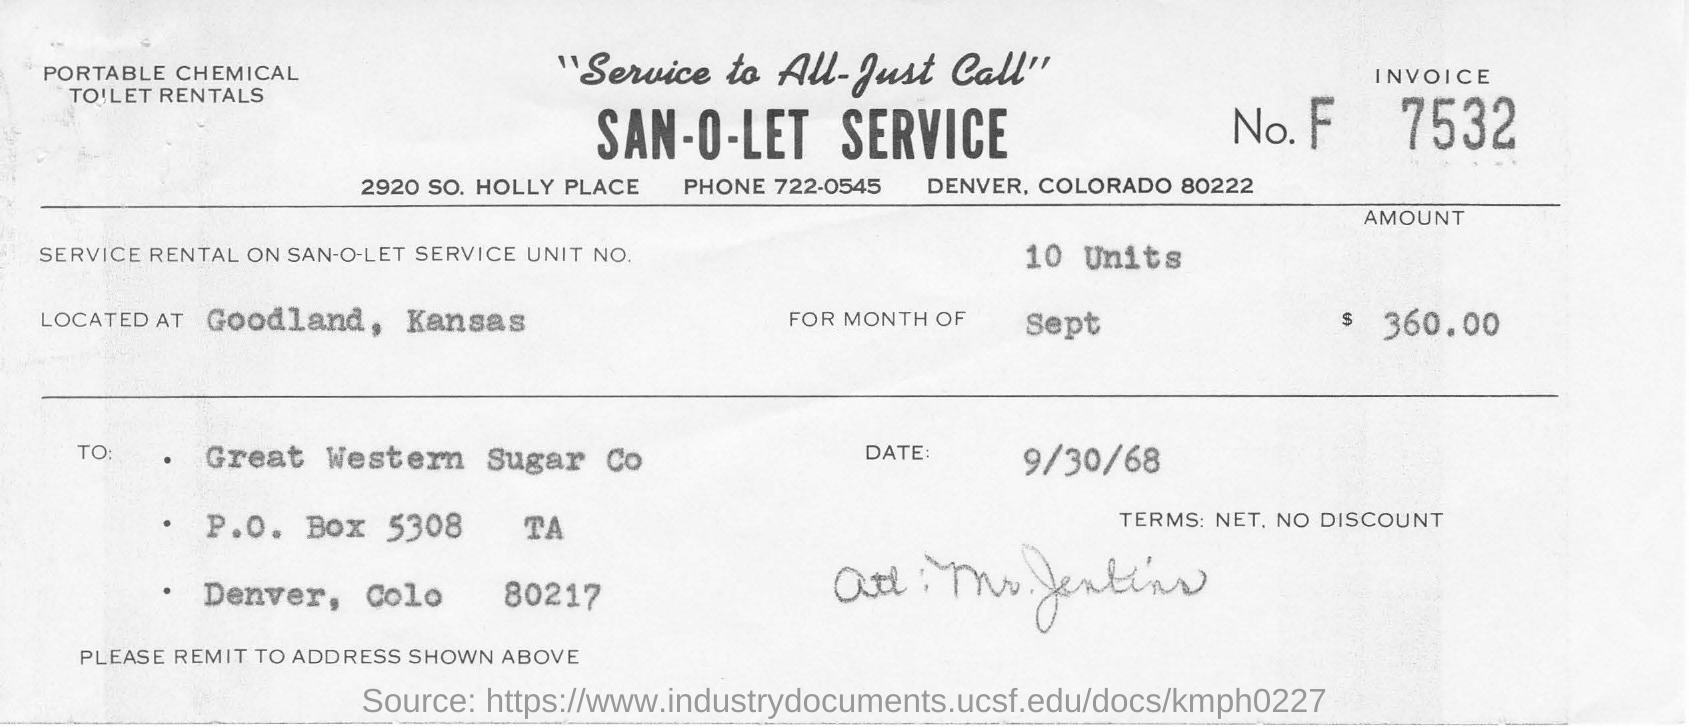What is the date mentioned in this document?
Ensure brevity in your answer.  9/30/68. What is the Invoice No given in this document?
Offer a terse response. F 7532. What is the service rental on San-o-let service  unit no?
Ensure brevity in your answer.  10 units. What is the phone no mentioned in this document?
Your answer should be very brief. 722-0545. 